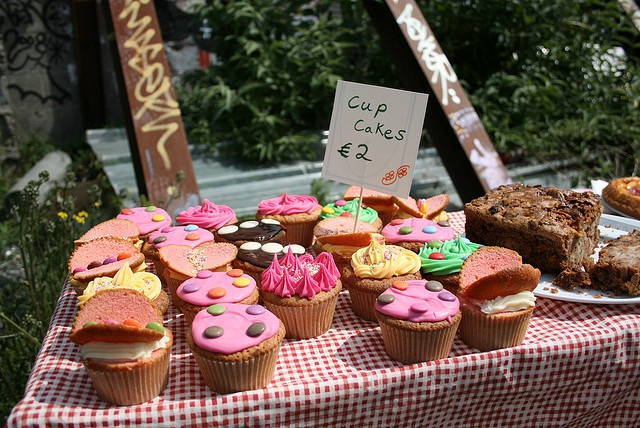Describe the objects in this image and their specific colors. I can see dining table in black, maroon, gray, lightgray, and brown tones, potted plant in black, gray, and darkgreen tones, cake in black, maroon, gray, and tan tones, cake in black, maroon, salmon, and brown tones, and cake in black, maroon, lightgray, and darkgray tones in this image. 